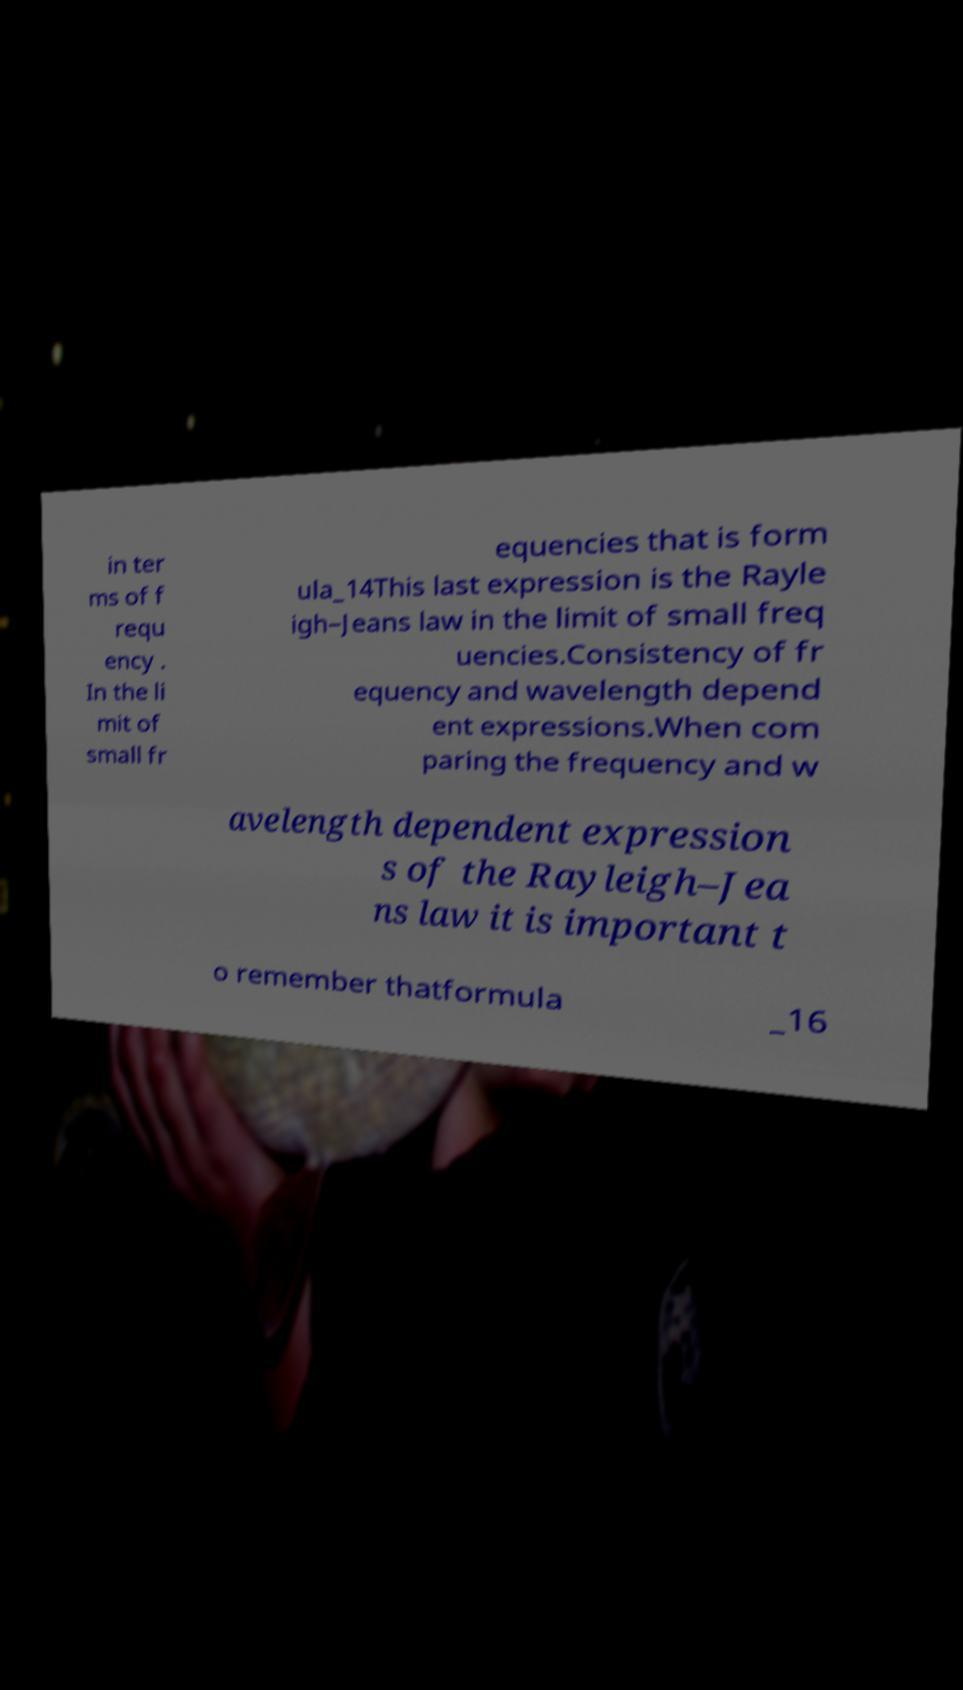I need the written content from this picture converted into text. Can you do that? in ter ms of f requ ency . In the li mit of small fr equencies that is form ula_14This last expression is the Rayle igh–Jeans law in the limit of small freq uencies.Consistency of fr equency and wavelength depend ent expressions.When com paring the frequency and w avelength dependent expression s of the Rayleigh–Jea ns law it is important t o remember thatformula _16 